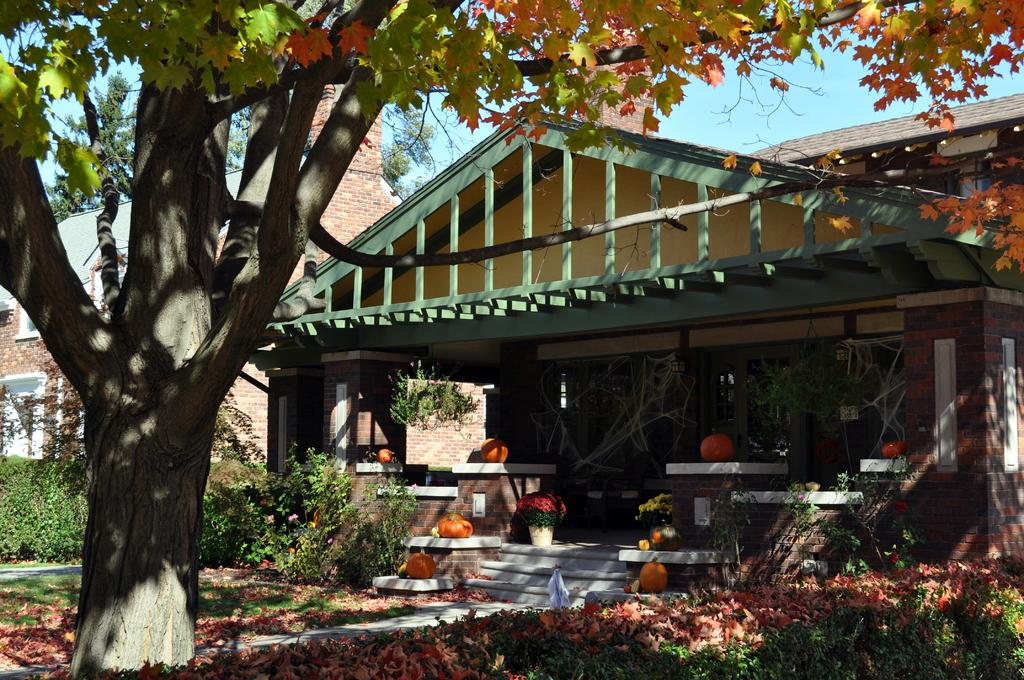How many houses are visible in the image? There are two houses in the image. What can be seen in front of one of the houses? There are pumpkins, steps, plants, grass, dried leaves, and a tree in front of one of the houses. What is visible in the background of the image? The sky is visible in the background of the image. What type of poison is being used to protect the pumpkins in the image? There is no poison present in the image; the pumpkins are not being protected in any way. What material is the clam made of in the image? There are no clams present in the image. 